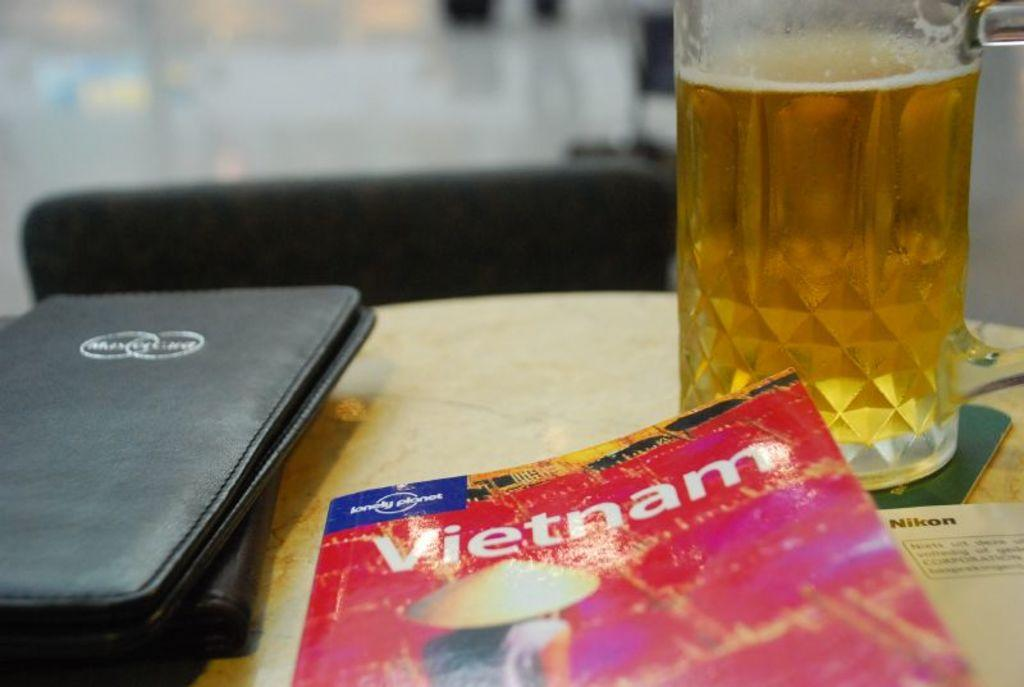<image>
Write a terse but informative summary of the picture. A magazine called "Vietnam" sits on a table next to a glass beverage and black wallet. 